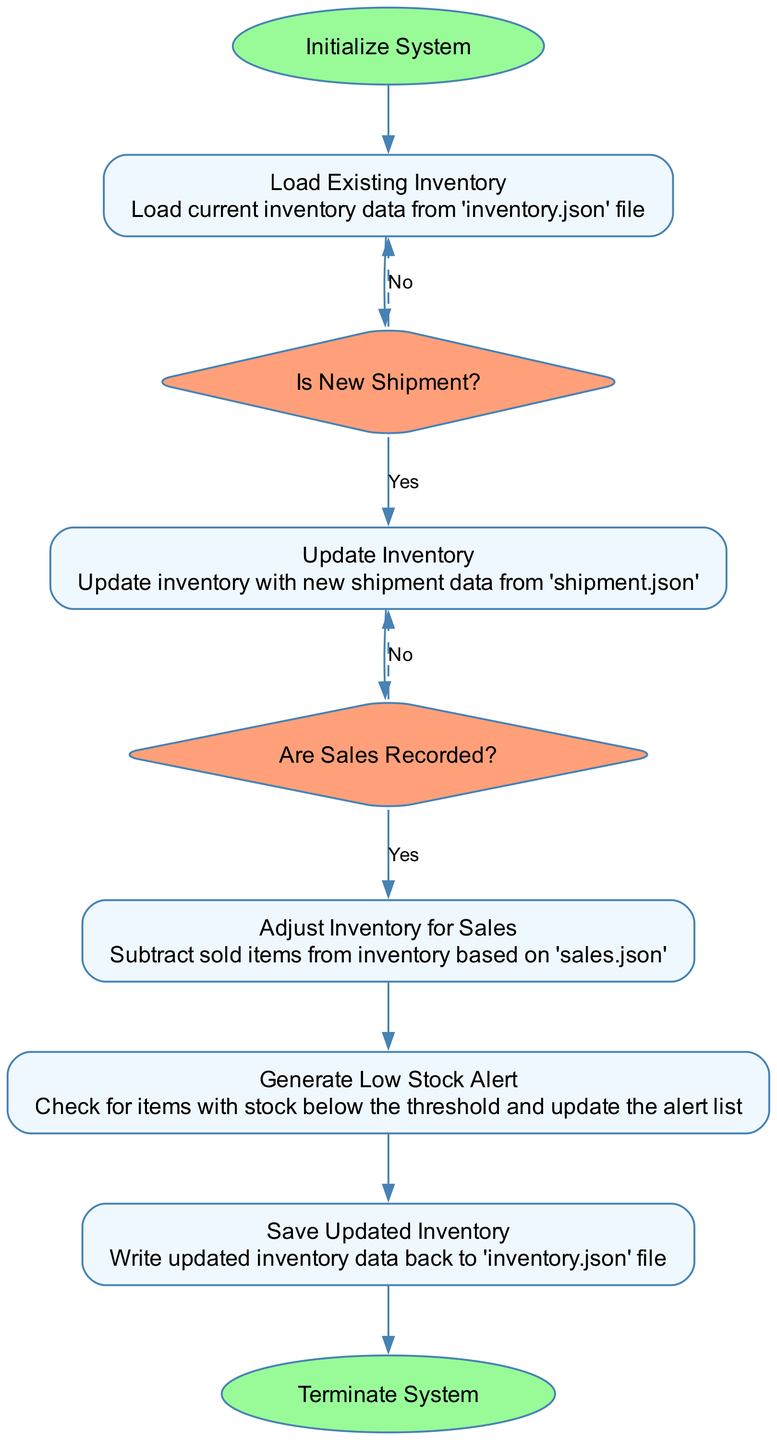What is the first step in the Inventory Management System? The first step in the diagram is labeled "Initialize System," indicating that the system starts with this action.
Answer: Initialize System What file is used to load the existing inventory? The diagram specifies that the existing inventory is loaded from the "inventory.json" file.
Answer: inventory.json How many decision nodes are present in the flowchart? By examining the diagram, there are a total of two decision nodes: "Is New Shipment?" and "Are Sales Recorded?".
Answer: 2 What happens if a new shipment is available? If a new shipment is available, the process "Update Inventory" is executed to incorporate the new shipment data.
Answer: Update Inventory What is the condition checked after updating the inventory? The next decision after updating the inventory checks "Are Sales Recorded?" to determine if there are any new sales records.
Answer: Are Sales Recorded? What is generated if stock is low? The process labeled "Generate Low Stock Alert" is executed to create alerts for items with stock levels below a specified threshold.
Answer: Generate Low Stock Alert If there are no new sales, which node does the flow return to? If there are no new sales recorded, the flow returns to the "Generate Low Stock Alert" node, as indicated by the dashed edge labeled 'No'.
Answer: Generate Low Stock Alert How is updated inventory saved? The flowchart indicates that updated inventory data is saved back into the "inventory.json" file during the "Save Updated Inventory" process.
Answer: inventory.json What is the final step of the flowchart? The final step in the flowchart is labeled "Terminate System," indicating the process's conclusion.
Answer: Terminate System 